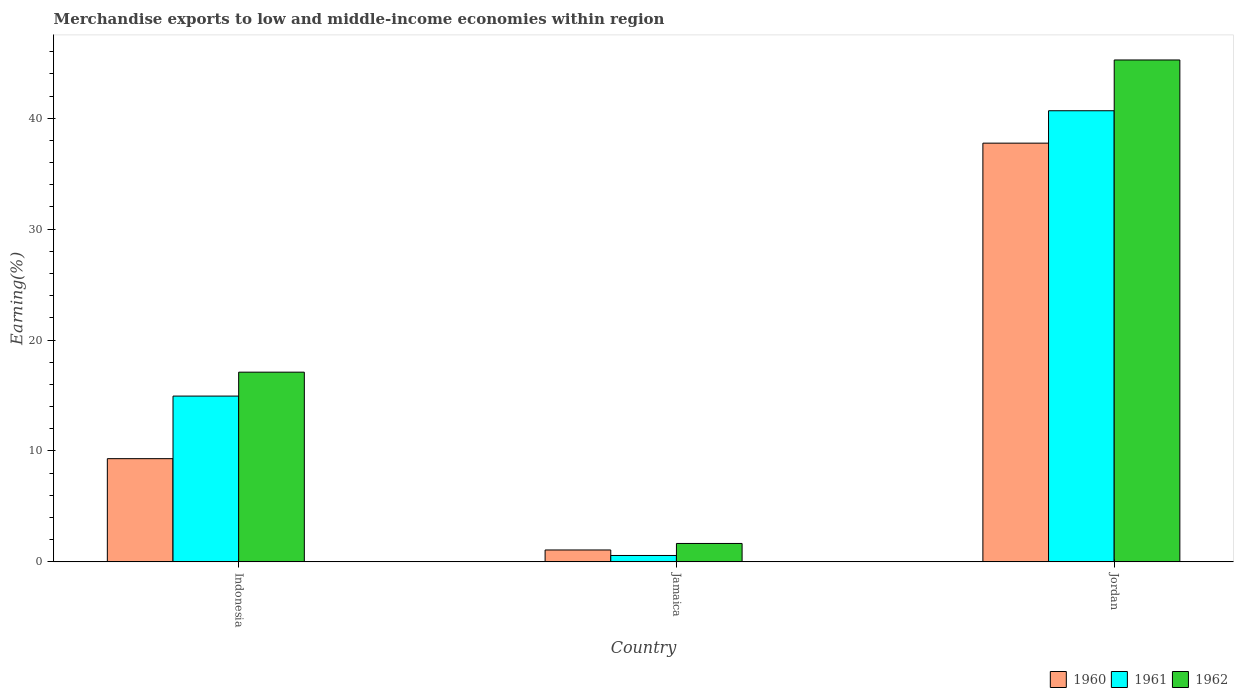Are the number of bars per tick equal to the number of legend labels?
Provide a short and direct response. Yes. How many bars are there on the 2nd tick from the left?
Ensure brevity in your answer.  3. What is the label of the 2nd group of bars from the left?
Keep it short and to the point. Jamaica. In how many cases, is the number of bars for a given country not equal to the number of legend labels?
Ensure brevity in your answer.  0. What is the percentage of amount earned from merchandise exports in 1962 in Indonesia?
Provide a succinct answer. 17.11. Across all countries, what is the maximum percentage of amount earned from merchandise exports in 1961?
Provide a short and direct response. 40.68. Across all countries, what is the minimum percentage of amount earned from merchandise exports in 1960?
Ensure brevity in your answer.  1.07. In which country was the percentage of amount earned from merchandise exports in 1962 maximum?
Your answer should be very brief. Jordan. In which country was the percentage of amount earned from merchandise exports in 1960 minimum?
Provide a short and direct response. Jamaica. What is the total percentage of amount earned from merchandise exports in 1960 in the graph?
Your answer should be very brief. 48.13. What is the difference between the percentage of amount earned from merchandise exports in 1961 in Jamaica and that in Jordan?
Offer a terse response. -40.1. What is the difference between the percentage of amount earned from merchandise exports in 1962 in Jamaica and the percentage of amount earned from merchandise exports in 1960 in Indonesia?
Offer a very short reply. -7.65. What is the average percentage of amount earned from merchandise exports in 1961 per country?
Ensure brevity in your answer.  18.73. What is the difference between the percentage of amount earned from merchandise exports of/in 1960 and percentage of amount earned from merchandise exports of/in 1962 in Jordan?
Offer a very short reply. -7.5. In how many countries, is the percentage of amount earned from merchandise exports in 1962 greater than 14 %?
Give a very brief answer. 2. What is the ratio of the percentage of amount earned from merchandise exports in 1962 in Jamaica to that in Jordan?
Give a very brief answer. 0.04. What is the difference between the highest and the second highest percentage of amount earned from merchandise exports in 1960?
Keep it short and to the point. -28.45. What is the difference between the highest and the lowest percentage of amount earned from merchandise exports in 1961?
Make the answer very short. 40.1. What does the 2nd bar from the left in Jordan represents?
Give a very brief answer. 1961. What does the 3rd bar from the right in Indonesia represents?
Your response must be concise. 1960. Is it the case that in every country, the sum of the percentage of amount earned from merchandise exports in 1962 and percentage of amount earned from merchandise exports in 1961 is greater than the percentage of amount earned from merchandise exports in 1960?
Your answer should be compact. Yes. What is the difference between two consecutive major ticks on the Y-axis?
Offer a very short reply. 10. Are the values on the major ticks of Y-axis written in scientific E-notation?
Provide a short and direct response. No. Does the graph contain any zero values?
Your answer should be compact. No. How are the legend labels stacked?
Give a very brief answer. Horizontal. What is the title of the graph?
Ensure brevity in your answer.  Merchandise exports to low and middle-income economies within region. What is the label or title of the Y-axis?
Ensure brevity in your answer.  Earning(%). What is the Earning(%) in 1960 in Indonesia?
Offer a very short reply. 9.31. What is the Earning(%) of 1961 in Indonesia?
Provide a short and direct response. 14.95. What is the Earning(%) in 1962 in Indonesia?
Make the answer very short. 17.11. What is the Earning(%) in 1960 in Jamaica?
Provide a short and direct response. 1.07. What is the Earning(%) in 1961 in Jamaica?
Offer a very short reply. 0.58. What is the Earning(%) of 1962 in Jamaica?
Provide a succinct answer. 1.66. What is the Earning(%) of 1960 in Jordan?
Give a very brief answer. 37.76. What is the Earning(%) in 1961 in Jordan?
Give a very brief answer. 40.68. What is the Earning(%) in 1962 in Jordan?
Offer a very short reply. 45.26. Across all countries, what is the maximum Earning(%) of 1960?
Provide a succinct answer. 37.76. Across all countries, what is the maximum Earning(%) in 1961?
Give a very brief answer. 40.68. Across all countries, what is the maximum Earning(%) in 1962?
Make the answer very short. 45.26. Across all countries, what is the minimum Earning(%) in 1960?
Offer a very short reply. 1.07. Across all countries, what is the minimum Earning(%) of 1961?
Your answer should be compact. 0.58. Across all countries, what is the minimum Earning(%) of 1962?
Give a very brief answer. 1.66. What is the total Earning(%) of 1960 in the graph?
Your answer should be compact. 48.13. What is the total Earning(%) in 1961 in the graph?
Provide a short and direct response. 56.2. What is the total Earning(%) of 1962 in the graph?
Ensure brevity in your answer.  64.02. What is the difference between the Earning(%) in 1960 in Indonesia and that in Jamaica?
Offer a very short reply. 8.23. What is the difference between the Earning(%) of 1961 in Indonesia and that in Jamaica?
Keep it short and to the point. 14.37. What is the difference between the Earning(%) in 1962 in Indonesia and that in Jamaica?
Give a very brief answer. 15.45. What is the difference between the Earning(%) of 1960 in Indonesia and that in Jordan?
Make the answer very short. -28.45. What is the difference between the Earning(%) in 1961 in Indonesia and that in Jordan?
Your answer should be compact. -25.73. What is the difference between the Earning(%) of 1962 in Indonesia and that in Jordan?
Your answer should be compact. -28.15. What is the difference between the Earning(%) of 1960 in Jamaica and that in Jordan?
Provide a short and direct response. -36.68. What is the difference between the Earning(%) of 1961 in Jamaica and that in Jordan?
Give a very brief answer. -40.1. What is the difference between the Earning(%) of 1962 in Jamaica and that in Jordan?
Offer a very short reply. -43.6. What is the difference between the Earning(%) in 1960 in Indonesia and the Earning(%) in 1961 in Jamaica?
Keep it short and to the point. 8.73. What is the difference between the Earning(%) of 1960 in Indonesia and the Earning(%) of 1962 in Jamaica?
Your response must be concise. 7.65. What is the difference between the Earning(%) of 1961 in Indonesia and the Earning(%) of 1962 in Jamaica?
Give a very brief answer. 13.29. What is the difference between the Earning(%) of 1960 in Indonesia and the Earning(%) of 1961 in Jordan?
Provide a succinct answer. -31.37. What is the difference between the Earning(%) in 1960 in Indonesia and the Earning(%) in 1962 in Jordan?
Offer a terse response. -35.95. What is the difference between the Earning(%) of 1961 in Indonesia and the Earning(%) of 1962 in Jordan?
Your answer should be very brief. -30.31. What is the difference between the Earning(%) in 1960 in Jamaica and the Earning(%) in 1961 in Jordan?
Make the answer very short. -39.6. What is the difference between the Earning(%) in 1960 in Jamaica and the Earning(%) in 1962 in Jordan?
Keep it short and to the point. -44.18. What is the difference between the Earning(%) in 1961 in Jamaica and the Earning(%) in 1962 in Jordan?
Provide a succinct answer. -44.68. What is the average Earning(%) of 1960 per country?
Provide a short and direct response. 16.04. What is the average Earning(%) of 1961 per country?
Offer a very short reply. 18.73. What is the average Earning(%) of 1962 per country?
Give a very brief answer. 21.34. What is the difference between the Earning(%) in 1960 and Earning(%) in 1961 in Indonesia?
Offer a very short reply. -5.64. What is the difference between the Earning(%) in 1960 and Earning(%) in 1962 in Indonesia?
Offer a very short reply. -7.8. What is the difference between the Earning(%) of 1961 and Earning(%) of 1962 in Indonesia?
Offer a very short reply. -2.16. What is the difference between the Earning(%) in 1960 and Earning(%) in 1961 in Jamaica?
Offer a very short reply. 0.5. What is the difference between the Earning(%) of 1960 and Earning(%) of 1962 in Jamaica?
Your answer should be very brief. -0.59. What is the difference between the Earning(%) of 1961 and Earning(%) of 1962 in Jamaica?
Provide a short and direct response. -1.08. What is the difference between the Earning(%) of 1960 and Earning(%) of 1961 in Jordan?
Your response must be concise. -2.92. What is the difference between the Earning(%) of 1960 and Earning(%) of 1962 in Jordan?
Provide a short and direct response. -7.5. What is the difference between the Earning(%) in 1961 and Earning(%) in 1962 in Jordan?
Keep it short and to the point. -4.58. What is the ratio of the Earning(%) of 1960 in Indonesia to that in Jamaica?
Offer a very short reply. 8.67. What is the ratio of the Earning(%) in 1961 in Indonesia to that in Jamaica?
Make the answer very short. 25.91. What is the ratio of the Earning(%) of 1962 in Indonesia to that in Jamaica?
Make the answer very short. 10.3. What is the ratio of the Earning(%) of 1960 in Indonesia to that in Jordan?
Provide a short and direct response. 0.25. What is the ratio of the Earning(%) in 1961 in Indonesia to that in Jordan?
Make the answer very short. 0.37. What is the ratio of the Earning(%) of 1962 in Indonesia to that in Jordan?
Ensure brevity in your answer.  0.38. What is the ratio of the Earning(%) of 1960 in Jamaica to that in Jordan?
Offer a very short reply. 0.03. What is the ratio of the Earning(%) in 1961 in Jamaica to that in Jordan?
Make the answer very short. 0.01. What is the ratio of the Earning(%) in 1962 in Jamaica to that in Jordan?
Provide a succinct answer. 0.04. What is the difference between the highest and the second highest Earning(%) in 1960?
Your answer should be very brief. 28.45. What is the difference between the highest and the second highest Earning(%) in 1961?
Provide a short and direct response. 25.73. What is the difference between the highest and the second highest Earning(%) of 1962?
Provide a succinct answer. 28.15. What is the difference between the highest and the lowest Earning(%) of 1960?
Provide a short and direct response. 36.68. What is the difference between the highest and the lowest Earning(%) in 1961?
Offer a very short reply. 40.1. What is the difference between the highest and the lowest Earning(%) of 1962?
Provide a succinct answer. 43.6. 